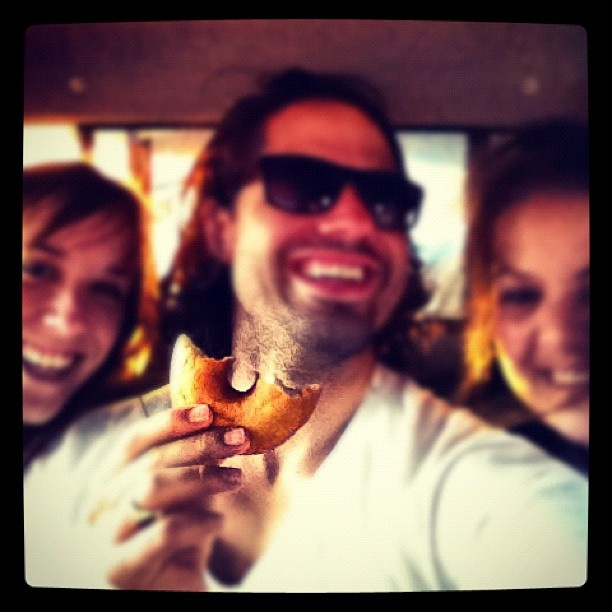Describe the objects in this image and their specific colors. I can see people in black, beige, and maroon tones, people in black, maroon, brown, and salmon tones, people in black, maroon, and brown tones, and donut in black, brown, red, orange, and maroon tones in this image. 